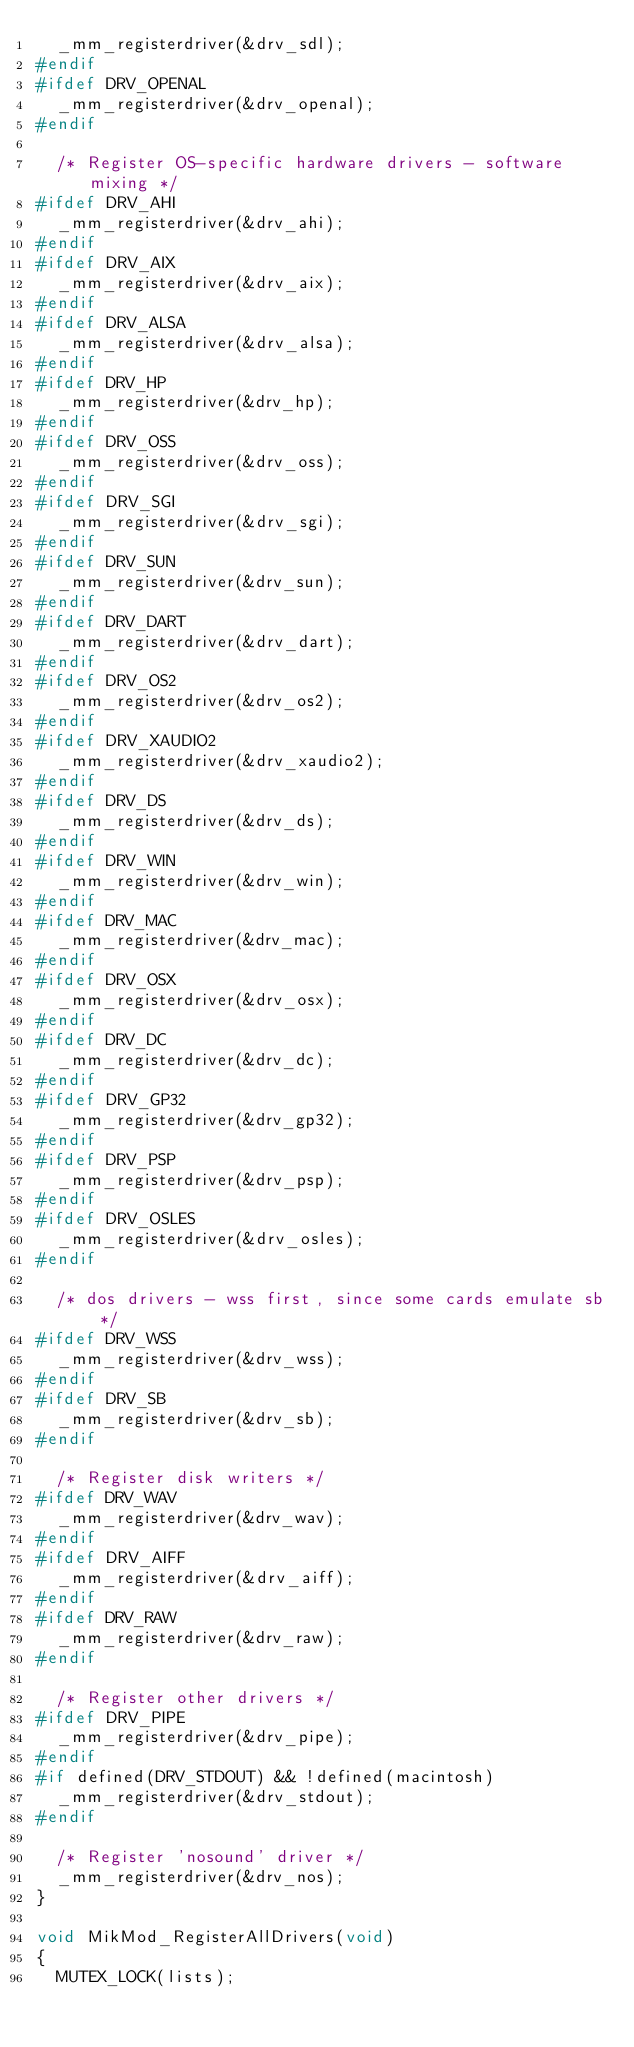Convert code to text. <code><loc_0><loc_0><loc_500><loc_500><_C_>	_mm_registerdriver(&drv_sdl);
#endif
#ifdef DRV_OPENAL
	_mm_registerdriver(&drv_openal);
#endif

	/* Register OS-specific hardware drivers - software mixing */
#ifdef DRV_AHI
	_mm_registerdriver(&drv_ahi);
#endif
#ifdef DRV_AIX
	_mm_registerdriver(&drv_aix);
#endif
#ifdef DRV_ALSA
	_mm_registerdriver(&drv_alsa);
#endif
#ifdef DRV_HP
	_mm_registerdriver(&drv_hp);
#endif
#ifdef DRV_OSS
	_mm_registerdriver(&drv_oss);
#endif
#ifdef DRV_SGI
	_mm_registerdriver(&drv_sgi);
#endif
#ifdef DRV_SUN
	_mm_registerdriver(&drv_sun);
#endif
#ifdef DRV_DART
	_mm_registerdriver(&drv_dart);
#endif
#ifdef DRV_OS2
	_mm_registerdriver(&drv_os2);
#endif
#ifdef DRV_XAUDIO2
	_mm_registerdriver(&drv_xaudio2);
#endif
#ifdef DRV_DS
	_mm_registerdriver(&drv_ds);
#endif
#ifdef DRV_WIN
	_mm_registerdriver(&drv_win);
#endif
#ifdef DRV_MAC
	_mm_registerdriver(&drv_mac);
#endif
#ifdef DRV_OSX
	_mm_registerdriver(&drv_osx);
#endif
#ifdef DRV_DC
	_mm_registerdriver(&drv_dc);
#endif
#ifdef DRV_GP32
	_mm_registerdriver(&drv_gp32);
#endif
#ifdef DRV_PSP
	_mm_registerdriver(&drv_psp);
#endif
#ifdef DRV_OSLES
	_mm_registerdriver(&drv_osles);
#endif

	/* dos drivers - wss first, since some cards emulate sb */
#ifdef DRV_WSS
	_mm_registerdriver(&drv_wss);
#endif
#ifdef DRV_SB
	_mm_registerdriver(&drv_sb);
#endif

	/* Register disk writers */
#ifdef DRV_WAV
	_mm_registerdriver(&drv_wav);
#endif
#ifdef DRV_AIFF
	_mm_registerdriver(&drv_aiff);
#endif
#ifdef DRV_RAW
	_mm_registerdriver(&drv_raw);
#endif

	/* Register other drivers */
#ifdef DRV_PIPE
	_mm_registerdriver(&drv_pipe);
#endif
#if defined(DRV_STDOUT) && !defined(macintosh)
	_mm_registerdriver(&drv_stdout);
#endif

	/* Register 'nosound' driver */
	_mm_registerdriver(&drv_nos);
}

void MikMod_RegisterAllDrivers(void)
{
	MUTEX_LOCK(lists);</code> 